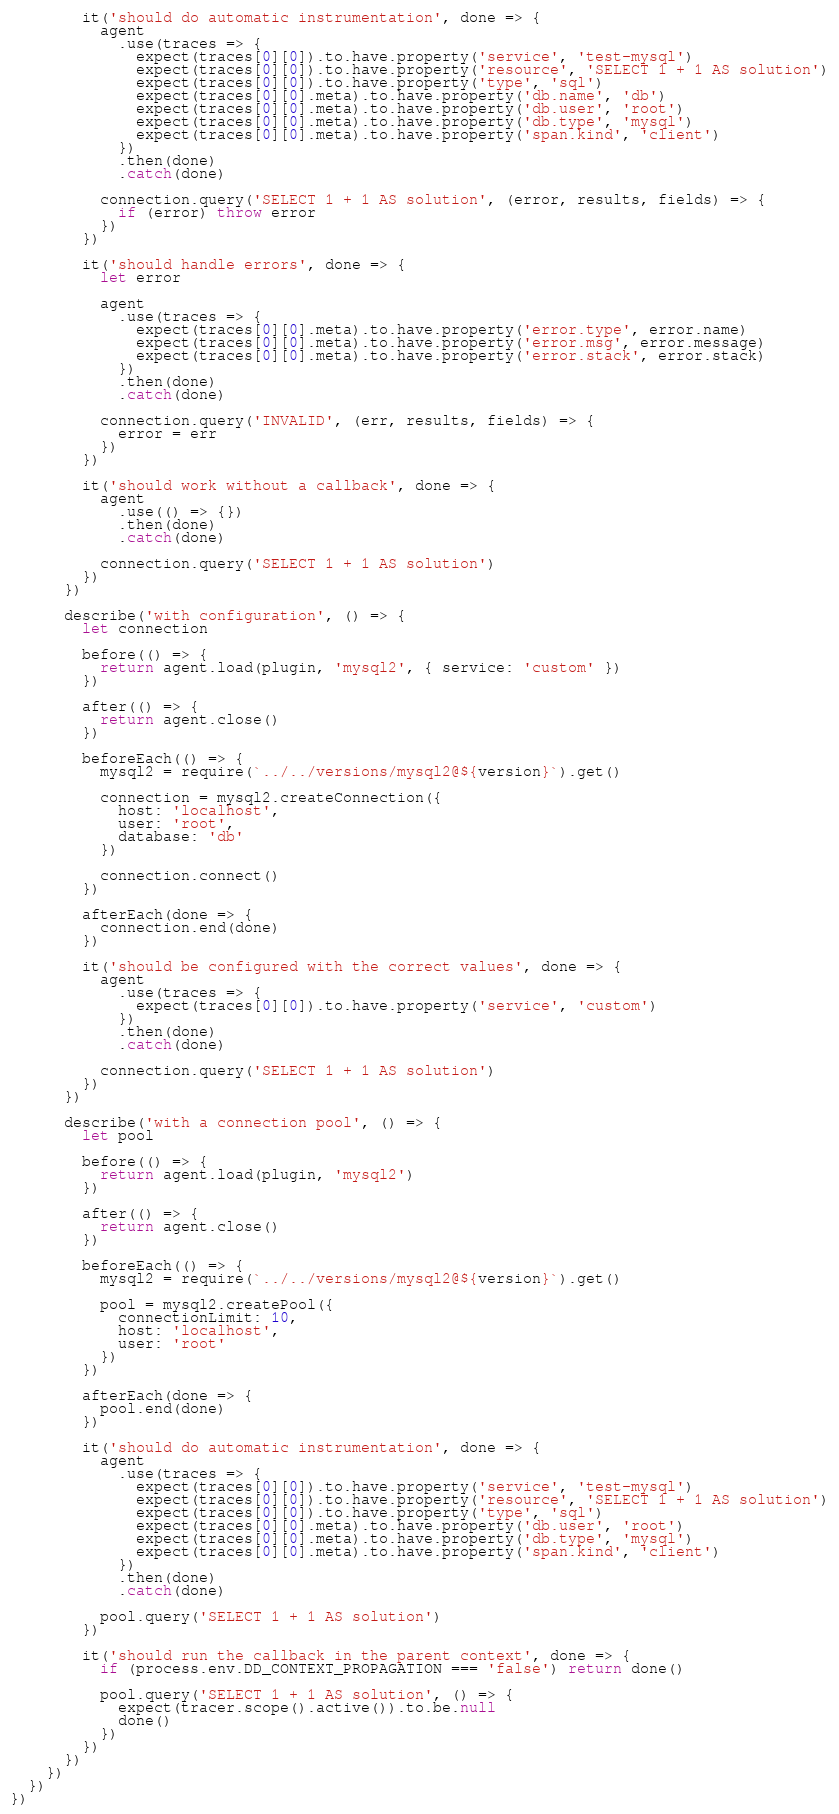<code> <loc_0><loc_0><loc_500><loc_500><_JavaScript_>        it('should do automatic instrumentation', done => {
          agent
            .use(traces => {
              expect(traces[0][0]).to.have.property('service', 'test-mysql')
              expect(traces[0][0]).to.have.property('resource', 'SELECT 1 + 1 AS solution')
              expect(traces[0][0]).to.have.property('type', 'sql')
              expect(traces[0][0].meta).to.have.property('db.name', 'db')
              expect(traces[0][0].meta).to.have.property('db.user', 'root')
              expect(traces[0][0].meta).to.have.property('db.type', 'mysql')
              expect(traces[0][0].meta).to.have.property('span.kind', 'client')
            })
            .then(done)
            .catch(done)

          connection.query('SELECT 1 + 1 AS solution', (error, results, fields) => {
            if (error) throw error
          })
        })

        it('should handle errors', done => {
          let error

          agent
            .use(traces => {
              expect(traces[0][0].meta).to.have.property('error.type', error.name)
              expect(traces[0][0].meta).to.have.property('error.msg', error.message)
              expect(traces[0][0].meta).to.have.property('error.stack', error.stack)
            })
            .then(done)
            .catch(done)

          connection.query('INVALID', (err, results, fields) => {
            error = err
          })
        })

        it('should work without a callback', done => {
          agent
            .use(() => {})
            .then(done)
            .catch(done)

          connection.query('SELECT 1 + 1 AS solution')
        })
      })

      describe('with configuration', () => {
        let connection

        before(() => {
          return agent.load(plugin, 'mysql2', { service: 'custom' })
        })

        after(() => {
          return agent.close()
        })

        beforeEach(() => {
          mysql2 = require(`../../versions/mysql2@${version}`).get()

          connection = mysql2.createConnection({
            host: 'localhost',
            user: 'root',
            database: 'db'
          })

          connection.connect()
        })

        afterEach(done => {
          connection.end(done)
        })

        it('should be configured with the correct values', done => {
          agent
            .use(traces => {
              expect(traces[0][0]).to.have.property('service', 'custom')
            })
            .then(done)
            .catch(done)

          connection.query('SELECT 1 + 1 AS solution')
        })
      })

      describe('with a connection pool', () => {
        let pool

        before(() => {
          return agent.load(plugin, 'mysql2')
        })

        after(() => {
          return agent.close()
        })

        beforeEach(() => {
          mysql2 = require(`../../versions/mysql2@${version}`).get()

          pool = mysql2.createPool({
            connectionLimit: 10,
            host: 'localhost',
            user: 'root'
          })
        })

        afterEach(done => {
          pool.end(done)
        })

        it('should do automatic instrumentation', done => {
          agent
            .use(traces => {
              expect(traces[0][0]).to.have.property('service', 'test-mysql')
              expect(traces[0][0]).to.have.property('resource', 'SELECT 1 + 1 AS solution')
              expect(traces[0][0]).to.have.property('type', 'sql')
              expect(traces[0][0].meta).to.have.property('db.user', 'root')
              expect(traces[0][0].meta).to.have.property('db.type', 'mysql')
              expect(traces[0][0].meta).to.have.property('span.kind', 'client')
            })
            .then(done)
            .catch(done)

          pool.query('SELECT 1 + 1 AS solution')
        })

        it('should run the callback in the parent context', done => {
          if (process.env.DD_CONTEXT_PROPAGATION === 'false') return done()

          pool.query('SELECT 1 + 1 AS solution', () => {
            expect(tracer.scope().active()).to.be.null
            done()
          })
        })
      })
    })
  })
})
</code> 